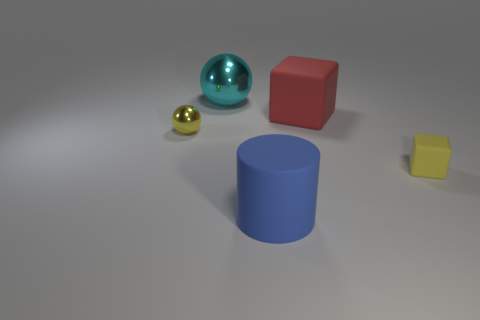Add 3 large brown balls. How many objects exist? 8 Subtract all yellow blocks. How many blocks are left? 1 Subtract all cylinders. How many objects are left? 4 Add 4 tiny matte things. How many tiny matte things are left? 5 Add 3 tiny yellow matte cubes. How many tiny yellow matte cubes exist? 4 Subtract 1 red cubes. How many objects are left? 4 Subtract all tiny blue metallic things. Subtract all cyan metal spheres. How many objects are left? 4 